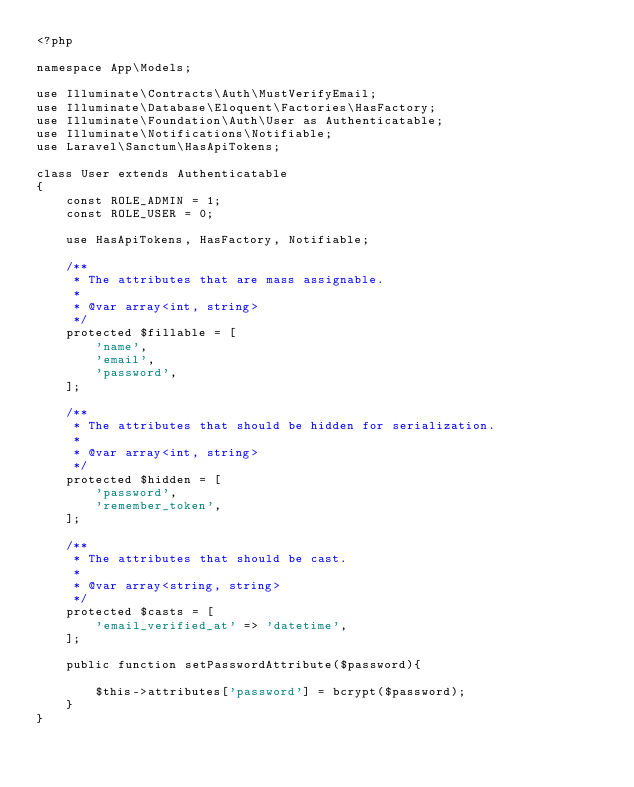Convert code to text. <code><loc_0><loc_0><loc_500><loc_500><_PHP_><?php

namespace App\Models;

use Illuminate\Contracts\Auth\MustVerifyEmail;
use Illuminate\Database\Eloquent\Factories\HasFactory;
use Illuminate\Foundation\Auth\User as Authenticatable;
use Illuminate\Notifications\Notifiable;
use Laravel\Sanctum\HasApiTokens;

class User extends Authenticatable
{
    const ROLE_ADMIN = 1;
    const ROLE_USER = 0;

    use HasApiTokens, HasFactory, Notifiable;

    /**
     * The attributes that are mass assignable.
     *
     * @var array<int, string>
     */
    protected $fillable = [
        'name',
        'email',
        'password',
    ];

    /**
     * The attributes that should be hidden for serialization.
     *
     * @var array<int, string>
     */
    protected $hidden = [
        'password',
        'remember_token',
    ];

    /**
     * The attributes that should be cast.
     *
     * @var array<string, string>
     */
    protected $casts = [
        'email_verified_at' => 'datetime',
    ];

    public function setPasswordAttribute($password){

        $this->attributes['password'] = bcrypt($password);
    }
}
</code> 